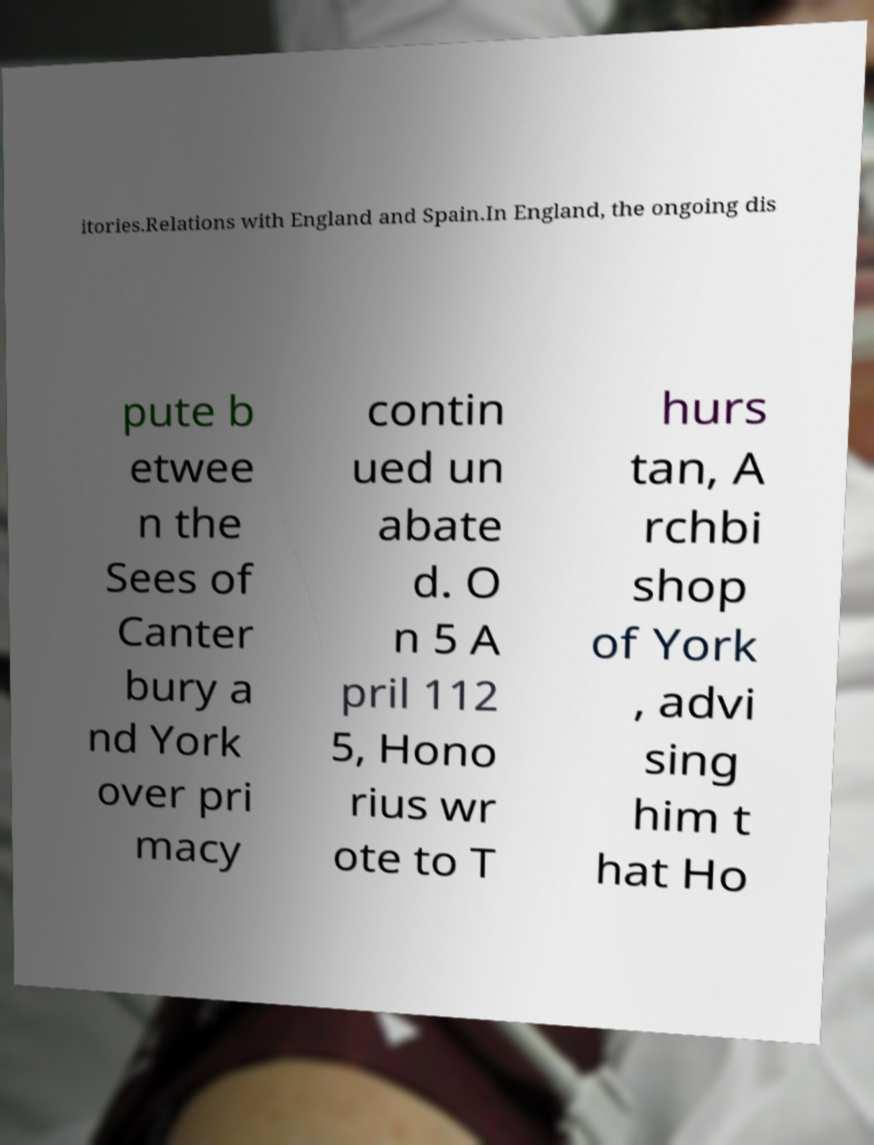Please identify and transcribe the text found in this image. itories.Relations with England and Spain.In England, the ongoing dis pute b etwee n the Sees of Canter bury a nd York over pri macy contin ued un abate d. O n 5 A pril 112 5, Hono rius wr ote to T hurs tan, A rchbi shop of York , advi sing him t hat Ho 